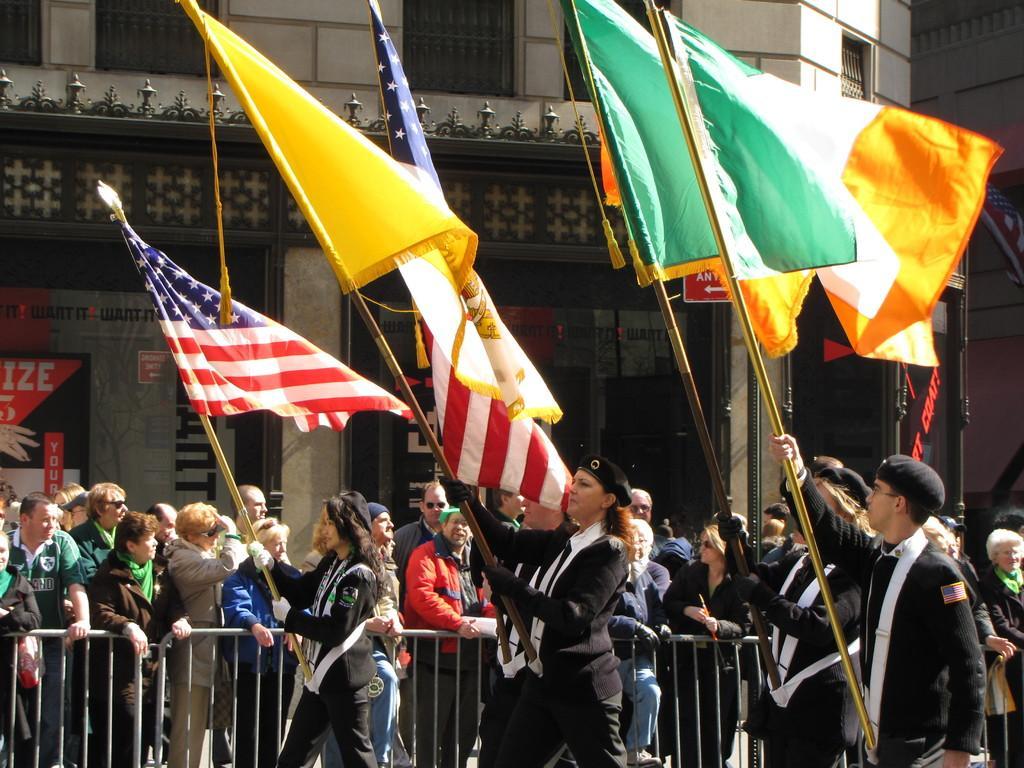Could you give a brief overview of what you see in this image? In this image there are people, raising, flags, building, poles and object. Among them few people are holding flags.   